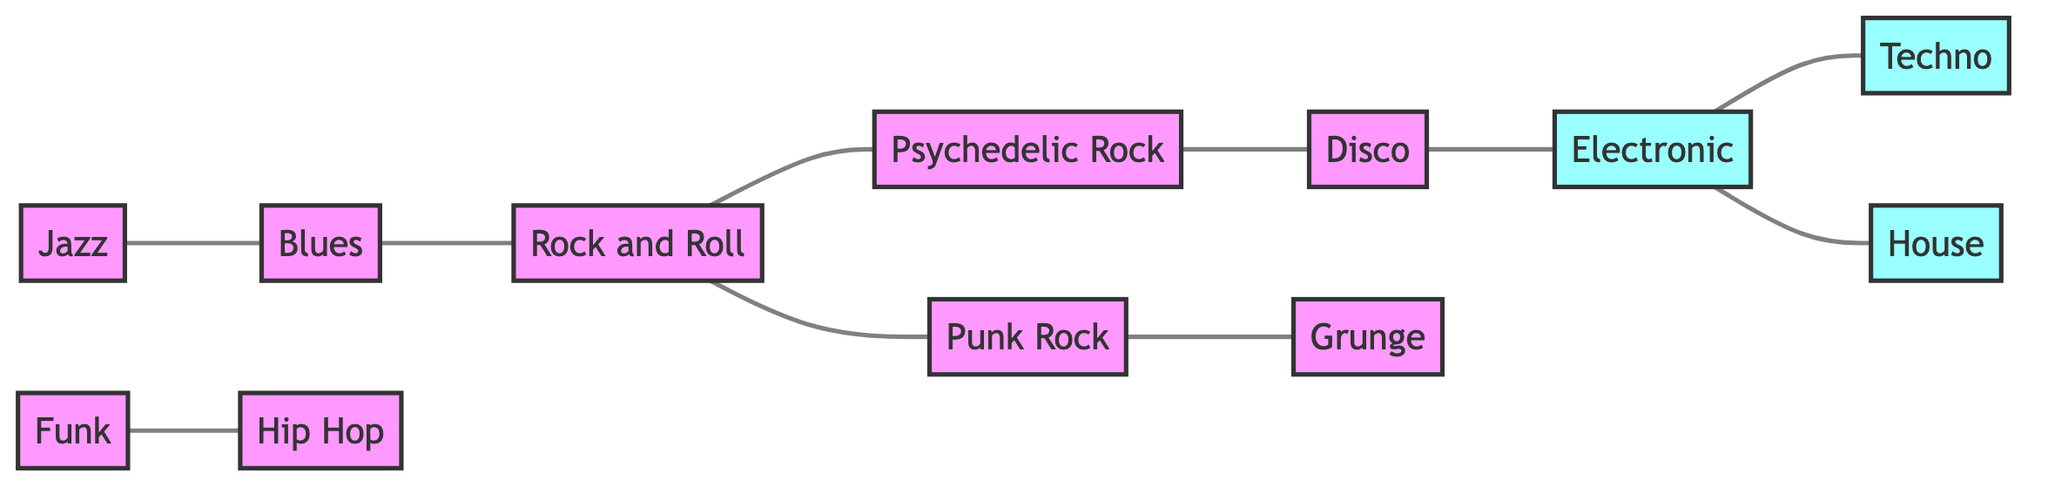What are the adjacent genres to Rock and Roll? To find the adjacent genres to Rock and Roll, I look for nodes directly connected to the Rock and Roll node. In the edges list, Rock and Roll connects to Blues, Psychedelic Rock, and Punk Rock.
Answer: Blues, Psychedelic Rock, Punk Rock How many genres are represented in the diagram? By counting the nodes provided in the diagram, I tally a total of 11 unique genres.
Answer: 11 Which genre is connected to Hip Hop? I examine the edges to determine which genre connects to Hip Hop. The edge shows that Funk is connected to Hip Hop.
Answer: Funk Which two genres are connected through Disco? I look for the node directly linked to Disco in the edges. Disco connects to Psychedelic Rock and Electronic, indicating the connection through Disco.
Answer: Psychedelic Rock, Electronic What is the relationship between Blues and Psychedelic Rock? To find the relationship, I check if there is a direct edge connecting Blues to Psychedelic Rock. The edges indicate that Blues is connected to Rock and Roll, which connects to Psychedelic Rock, indicating an indirect relationship.
Answer: Indirectly connected Which genre has the most connections? I assess the number of edges connected to each genre. Rock and Roll connects to Blues, Psychedelic Rock, and Punk Rock, totaling 4 connections.
Answer: Rock and Roll How many electronic genres are there? I check the nodes looking for genres categorized as electronic types. The diagram includes Electronic, Techno, and House as electronic genres.
Answer: 3 Which genres follow the evolution from Jazz? I trace the connections starting from Jazz. The edges indicate that Jazz connects to Blues, which connects to Rock and Roll, leading to Psychedelic Rock. Thus, the evolution from Jazz follows into Blues, Rock and Roll, and Psychedelic Rock.
Answer: Blues, Rock and Roll, Psychedelic Rock What genre precedes Grunge? I look at the edges to find the node that connects directly to Grunge. The edge shows that Punk Rock precedes Grunge in the diagram.
Answer: Punk Rock 